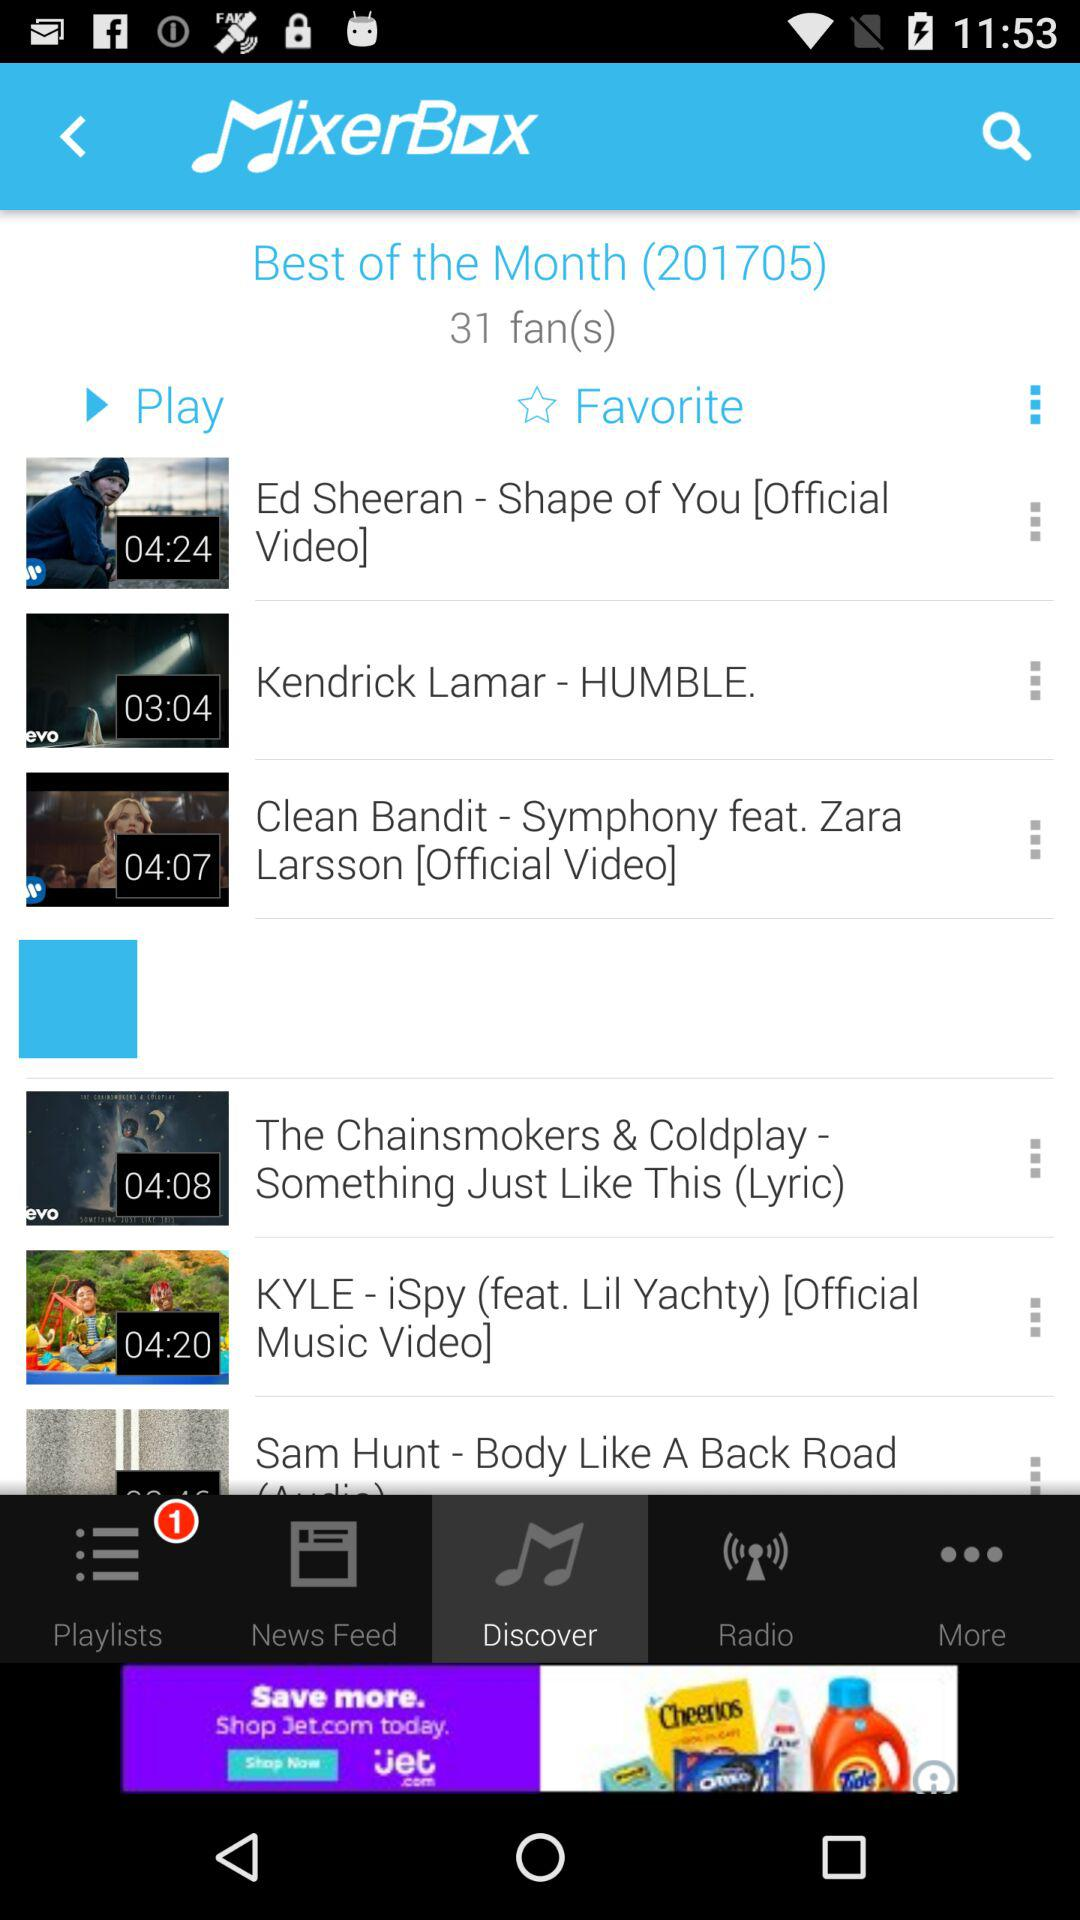Which tab is selected? The selected tab is "Discover". 